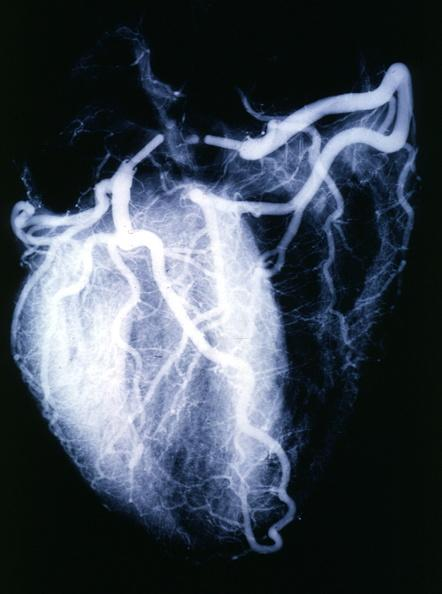what does this image show?
Answer the question using a single word or phrase. X-ray postmortnormal coronaries 